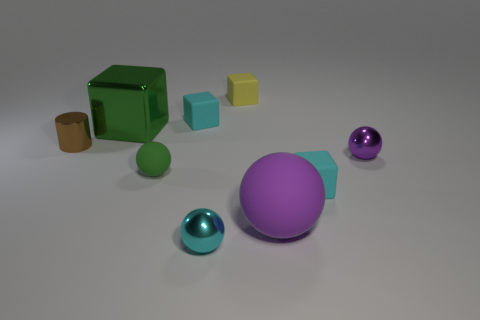Add 1 big metallic objects. How many objects exist? 10 Subtract all big purple matte spheres. How many spheres are left? 3 Subtract all green cylinders. How many purple spheres are left? 2 Subtract 2 blocks. How many blocks are left? 2 Subtract all green blocks. How many blocks are left? 3 Subtract all cubes. How many objects are left? 5 Subtract all blue blocks. Subtract all purple balls. How many blocks are left? 4 Subtract 2 purple balls. How many objects are left? 7 Subtract all big green metallic cubes. Subtract all small things. How many objects are left? 1 Add 2 tiny shiny spheres. How many tiny shiny spheres are left? 4 